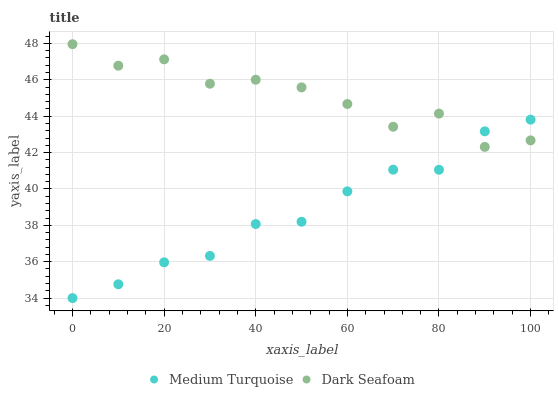Does Medium Turquoise have the minimum area under the curve?
Answer yes or no. Yes. Does Dark Seafoam have the maximum area under the curve?
Answer yes or no. Yes. Does Medium Turquoise have the maximum area under the curve?
Answer yes or no. No. Is Medium Turquoise the smoothest?
Answer yes or no. Yes. Is Dark Seafoam the roughest?
Answer yes or no. Yes. Is Medium Turquoise the roughest?
Answer yes or no. No. Does Medium Turquoise have the lowest value?
Answer yes or no. Yes. Does Dark Seafoam have the highest value?
Answer yes or no. Yes. Does Medium Turquoise have the highest value?
Answer yes or no. No. Does Dark Seafoam intersect Medium Turquoise?
Answer yes or no. Yes. Is Dark Seafoam less than Medium Turquoise?
Answer yes or no. No. Is Dark Seafoam greater than Medium Turquoise?
Answer yes or no. No. 